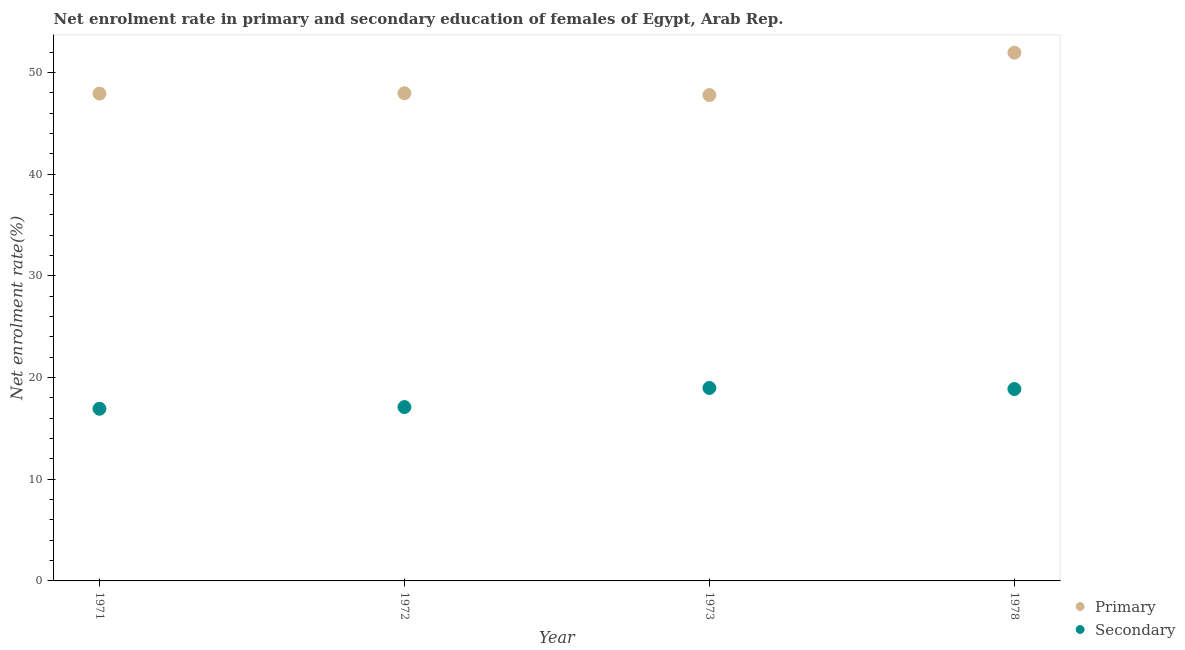Is the number of dotlines equal to the number of legend labels?
Offer a terse response. Yes. What is the enrollment rate in secondary education in 1973?
Your answer should be very brief. 18.98. Across all years, what is the maximum enrollment rate in secondary education?
Give a very brief answer. 18.98. Across all years, what is the minimum enrollment rate in primary education?
Offer a terse response. 47.79. In which year was the enrollment rate in primary education maximum?
Your answer should be compact. 1978. In which year was the enrollment rate in secondary education minimum?
Your answer should be compact. 1971. What is the total enrollment rate in primary education in the graph?
Your answer should be very brief. 195.64. What is the difference between the enrollment rate in primary education in 1972 and that in 1973?
Your answer should be compact. 0.18. What is the difference between the enrollment rate in secondary education in 1973 and the enrollment rate in primary education in 1971?
Provide a succinct answer. -28.95. What is the average enrollment rate in primary education per year?
Offer a very short reply. 48.91. In the year 1971, what is the difference between the enrollment rate in primary education and enrollment rate in secondary education?
Your response must be concise. 31. In how many years, is the enrollment rate in primary education greater than 22 %?
Give a very brief answer. 4. What is the ratio of the enrollment rate in primary education in 1971 to that in 1972?
Make the answer very short. 1. Is the difference between the enrollment rate in primary education in 1973 and 1978 greater than the difference between the enrollment rate in secondary education in 1973 and 1978?
Offer a very short reply. No. What is the difference between the highest and the second highest enrollment rate in secondary education?
Your answer should be very brief. 0.1. What is the difference between the highest and the lowest enrollment rate in primary education?
Ensure brevity in your answer.  4.17. In how many years, is the enrollment rate in primary education greater than the average enrollment rate in primary education taken over all years?
Provide a succinct answer. 1. Is the sum of the enrollment rate in secondary education in 1971 and 1973 greater than the maximum enrollment rate in primary education across all years?
Give a very brief answer. No. Does the enrollment rate in primary education monotonically increase over the years?
Your response must be concise. No. Is the enrollment rate in primary education strictly greater than the enrollment rate in secondary education over the years?
Provide a short and direct response. Yes. Is the enrollment rate in primary education strictly less than the enrollment rate in secondary education over the years?
Give a very brief answer. No. Does the graph contain grids?
Your response must be concise. No. Where does the legend appear in the graph?
Make the answer very short. Bottom right. How many legend labels are there?
Offer a terse response. 2. What is the title of the graph?
Provide a succinct answer. Net enrolment rate in primary and secondary education of females of Egypt, Arab Rep. Does "Male entrants" appear as one of the legend labels in the graph?
Make the answer very short. No. What is the label or title of the X-axis?
Make the answer very short. Year. What is the label or title of the Y-axis?
Ensure brevity in your answer.  Net enrolment rate(%). What is the Net enrolment rate(%) of Primary in 1971?
Give a very brief answer. 47.93. What is the Net enrolment rate(%) in Secondary in 1971?
Your answer should be very brief. 16.93. What is the Net enrolment rate(%) of Primary in 1972?
Your response must be concise. 47.97. What is the Net enrolment rate(%) in Secondary in 1972?
Provide a succinct answer. 17.1. What is the Net enrolment rate(%) in Primary in 1973?
Make the answer very short. 47.79. What is the Net enrolment rate(%) in Secondary in 1973?
Your response must be concise. 18.98. What is the Net enrolment rate(%) of Primary in 1978?
Keep it short and to the point. 51.96. What is the Net enrolment rate(%) in Secondary in 1978?
Give a very brief answer. 18.88. Across all years, what is the maximum Net enrolment rate(%) of Primary?
Your response must be concise. 51.96. Across all years, what is the maximum Net enrolment rate(%) in Secondary?
Offer a terse response. 18.98. Across all years, what is the minimum Net enrolment rate(%) of Primary?
Your response must be concise. 47.79. Across all years, what is the minimum Net enrolment rate(%) of Secondary?
Your answer should be very brief. 16.93. What is the total Net enrolment rate(%) of Primary in the graph?
Your response must be concise. 195.64. What is the total Net enrolment rate(%) of Secondary in the graph?
Provide a succinct answer. 71.89. What is the difference between the Net enrolment rate(%) of Primary in 1971 and that in 1972?
Your answer should be very brief. -0.04. What is the difference between the Net enrolment rate(%) of Secondary in 1971 and that in 1972?
Ensure brevity in your answer.  -0.17. What is the difference between the Net enrolment rate(%) in Primary in 1971 and that in 1973?
Provide a short and direct response. 0.14. What is the difference between the Net enrolment rate(%) in Secondary in 1971 and that in 1973?
Your response must be concise. -2.05. What is the difference between the Net enrolment rate(%) of Primary in 1971 and that in 1978?
Give a very brief answer. -4.03. What is the difference between the Net enrolment rate(%) in Secondary in 1971 and that in 1978?
Make the answer very short. -1.94. What is the difference between the Net enrolment rate(%) of Primary in 1972 and that in 1973?
Provide a short and direct response. 0.18. What is the difference between the Net enrolment rate(%) in Secondary in 1972 and that in 1973?
Your answer should be compact. -1.88. What is the difference between the Net enrolment rate(%) of Primary in 1972 and that in 1978?
Keep it short and to the point. -3.99. What is the difference between the Net enrolment rate(%) in Secondary in 1972 and that in 1978?
Your response must be concise. -1.77. What is the difference between the Net enrolment rate(%) of Primary in 1973 and that in 1978?
Your answer should be very brief. -4.17. What is the difference between the Net enrolment rate(%) of Secondary in 1973 and that in 1978?
Provide a succinct answer. 0.1. What is the difference between the Net enrolment rate(%) in Primary in 1971 and the Net enrolment rate(%) in Secondary in 1972?
Make the answer very short. 30.83. What is the difference between the Net enrolment rate(%) of Primary in 1971 and the Net enrolment rate(%) of Secondary in 1973?
Provide a short and direct response. 28.95. What is the difference between the Net enrolment rate(%) of Primary in 1971 and the Net enrolment rate(%) of Secondary in 1978?
Keep it short and to the point. 29.05. What is the difference between the Net enrolment rate(%) of Primary in 1972 and the Net enrolment rate(%) of Secondary in 1973?
Your answer should be very brief. 28.99. What is the difference between the Net enrolment rate(%) in Primary in 1972 and the Net enrolment rate(%) in Secondary in 1978?
Offer a terse response. 29.09. What is the difference between the Net enrolment rate(%) in Primary in 1973 and the Net enrolment rate(%) in Secondary in 1978?
Ensure brevity in your answer.  28.91. What is the average Net enrolment rate(%) in Primary per year?
Ensure brevity in your answer.  48.91. What is the average Net enrolment rate(%) of Secondary per year?
Give a very brief answer. 17.97. In the year 1971, what is the difference between the Net enrolment rate(%) of Primary and Net enrolment rate(%) of Secondary?
Provide a short and direct response. 31. In the year 1972, what is the difference between the Net enrolment rate(%) in Primary and Net enrolment rate(%) in Secondary?
Keep it short and to the point. 30.87. In the year 1973, what is the difference between the Net enrolment rate(%) in Primary and Net enrolment rate(%) in Secondary?
Ensure brevity in your answer.  28.81. In the year 1978, what is the difference between the Net enrolment rate(%) of Primary and Net enrolment rate(%) of Secondary?
Your answer should be compact. 33.08. What is the ratio of the Net enrolment rate(%) in Secondary in 1971 to that in 1972?
Make the answer very short. 0.99. What is the ratio of the Net enrolment rate(%) of Primary in 1971 to that in 1973?
Keep it short and to the point. 1. What is the ratio of the Net enrolment rate(%) in Secondary in 1971 to that in 1973?
Make the answer very short. 0.89. What is the ratio of the Net enrolment rate(%) in Primary in 1971 to that in 1978?
Offer a very short reply. 0.92. What is the ratio of the Net enrolment rate(%) of Secondary in 1971 to that in 1978?
Your answer should be compact. 0.9. What is the ratio of the Net enrolment rate(%) in Primary in 1972 to that in 1973?
Your response must be concise. 1. What is the ratio of the Net enrolment rate(%) of Secondary in 1972 to that in 1973?
Your answer should be compact. 0.9. What is the ratio of the Net enrolment rate(%) of Primary in 1972 to that in 1978?
Give a very brief answer. 0.92. What is the ratio of the Net enrolment rate(%) in Secondary in 1972 to that in 1978?
Offer a very short reply. 0.91. What is the ratio of the Net enrolment rate(%) in Primary in 1973 to that in 1978?
Keep it short and to the point. 0.92. What is the difference between the highest and the second highest Net enrolment rate(%) of Primary?
Offer a terse response. 3.99. What is the difference between the highest and the second highest Net enrolment rate(%) in Secondary?
Give a very brief answer. 0.1. What is the difference between the highest and the lowest Net enrolment rate(%) of Primary?
Provide a short and direct response. 4.17. What is the difference between the highest and the lowest Net enrolment rate(%) of Secondary?
Provide a short and direct response. 2.05. 